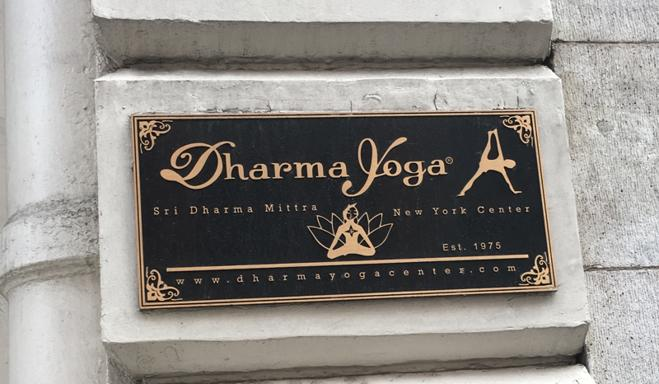What does the logo on the sign represent? The logo on the sign, featuring a stylized figure in a lotus position, represents the essence of yoga - balance, harmony, and inner peace. This symbol, often used in yoga practice, highlights the center's focus on traditional and spiritual aspects of yoga. 